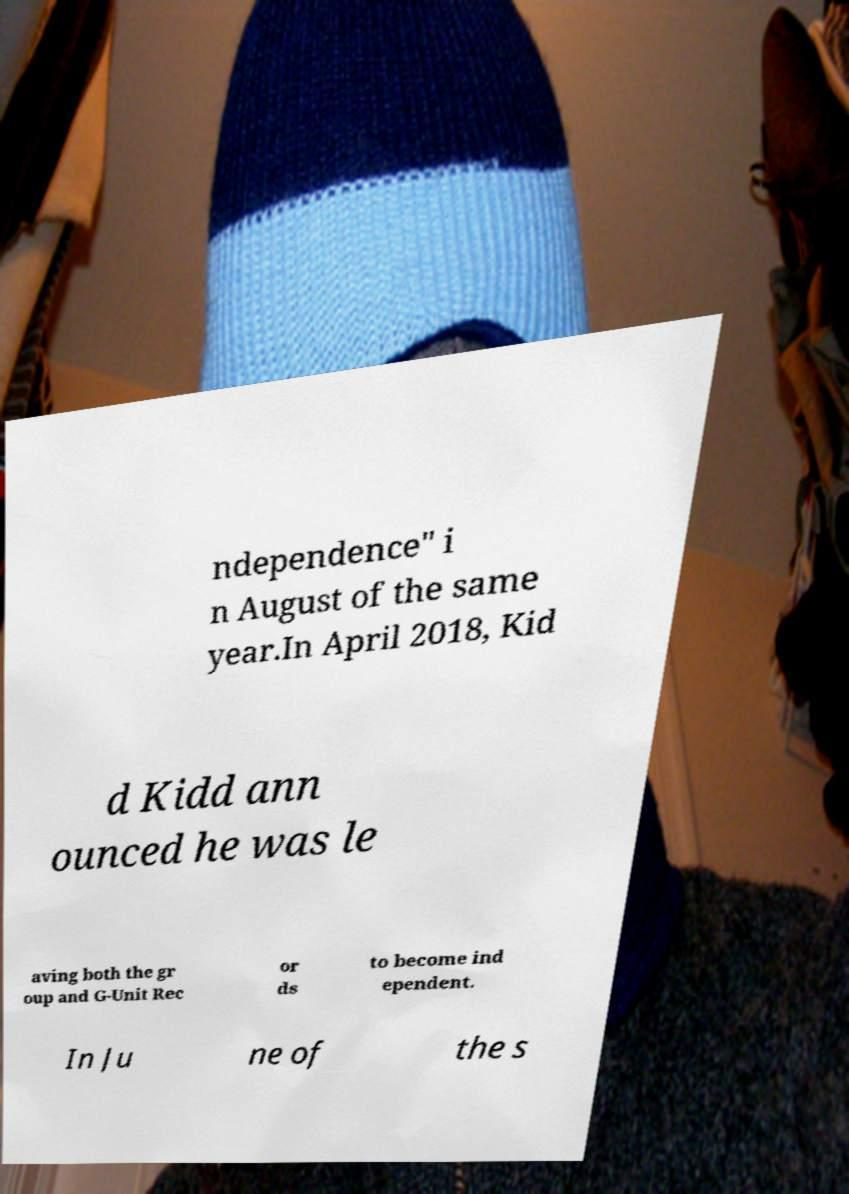Could you extract and type out the text from this image? ndependence" i n August of the same year.In April 2018, Kid d Kidd ann ounced he was le aving both the gr oup and G-Unit Rec or ds to become ind ependent. In Ju ne of the s 